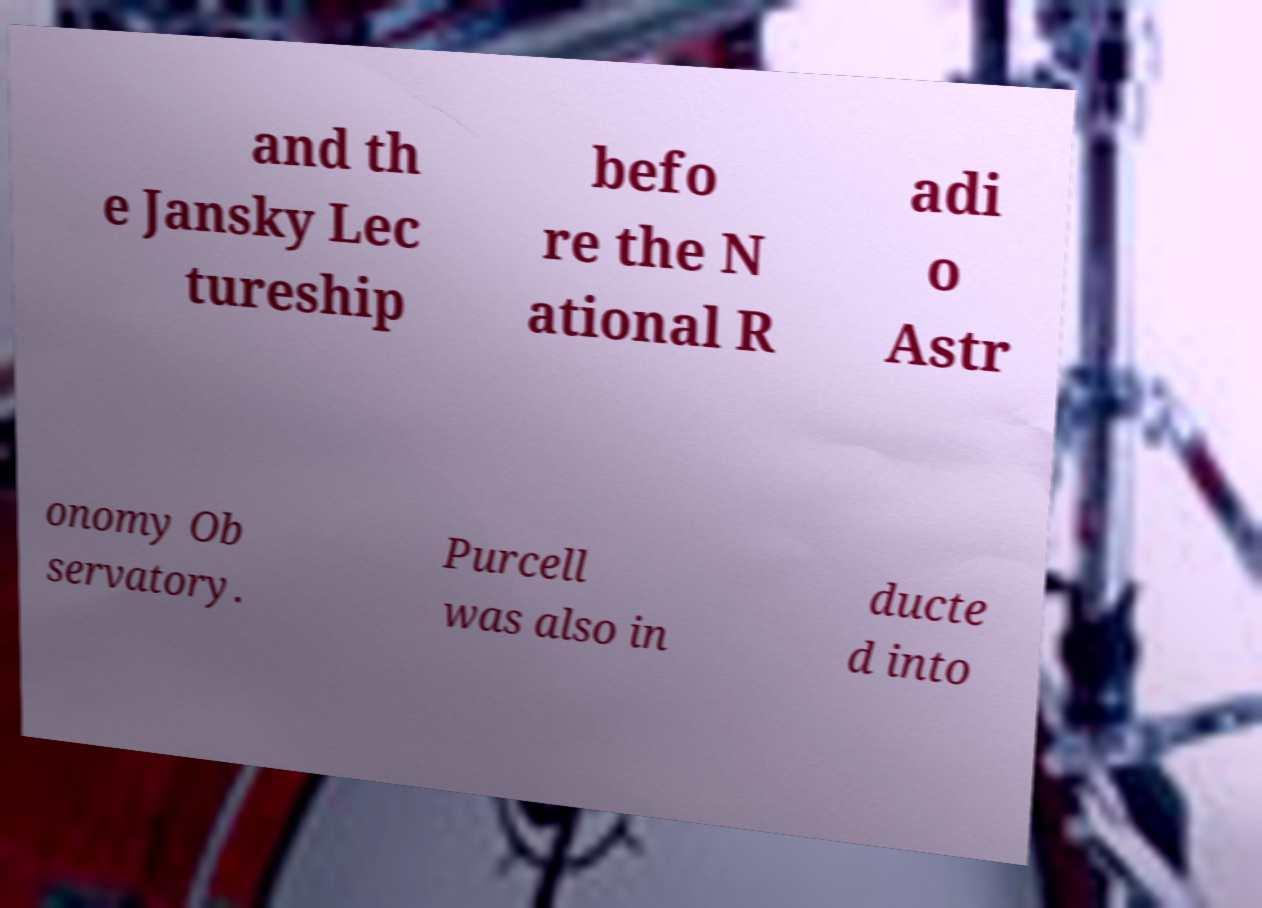Could you assist in decoding the text presented in this image and type it out clearly? and th e Jansky Lec tureship befo re the N ational R adi o Astr onomy Ob servatory. Purcell was also in ducte d into 